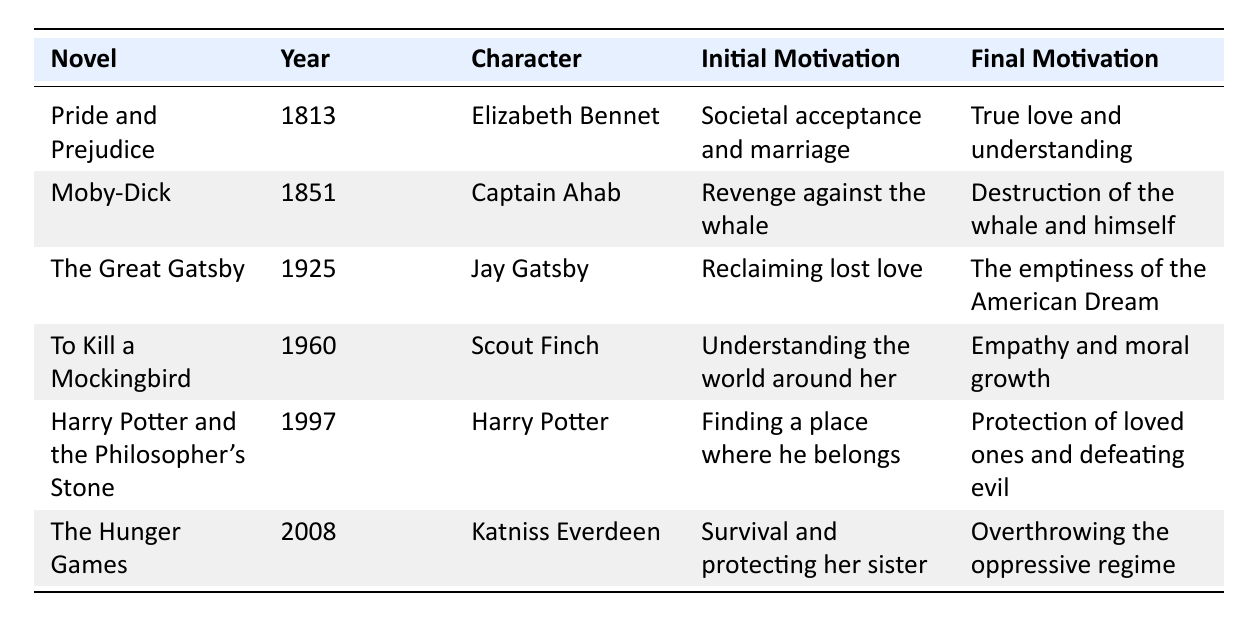What is the title of the novel published in 1925? The table lists the novel titles along with their publication years. By locating the year 1925 in the "Year" column, we find that the corresponding novel is "The Great Gatsby."
Answer: The Great Gatsby Who is the main character of "To Kill a Mockingbird"? The table specifies the main characters for each novel under the "Character" column. For the novel "To Kill a Mockingbird," the main character listed is "Scout Finch."
Answer: Scout Finch What was Elizabeth Bennet's initial motivation? The initial motivation for each character is given in the "Initial Motivation" column. For Elizabeth Bennet from "Pride and Prejudice," her initial motivation is societal acceptance and marriage.
Answer: Societal acceptance and marriage How many novels were published after 1950? To answer, we check the publication years in the "Year" column and count the novels published after 1950. The novels "To Kill a Mockingbird," "Harry Potter and the Philosopher's Stone," and "The Hunger Games" were published after 1950, totaling 3 novels.
Answer: 3 Which character transitions from revenge to self-destruction? By examining the evolution of each character in the table, we look for one whose journey ends in self-destruction. Captain Ahab from "Moby-Dick" evolves from seeking revenge against the whale to destruction of the whale and himself.
Answer: Captain Ahab Is Scout Finch's final motivation related to social issues? Examining the final motivations listed in the table, we see that Scout Finch's final motivation is empathy and moral growth, which indicates awareness of social issues. Therefore, the answer is yes.
Answer: Yes Which character experiences a change in motivation related to the concept of love? We review the "Initial Motivation" and "Final Motivation" columns for any characters associated with love. Jay Gatsby in "The Great Gatsby" starts with reclaiming lost love and ends with the realization of the emptiness of the American Dream, linking both motivations to love.
Answer: Jay Gatsby What is the difference between Katniss Everdeen's initial and final motivations? To find the difference, we identify Katniss Everdeen's initial motivation (survival and protecting her sister) and her final motivation (overthrowing the oppressive regime). The difference reflects a transition from personal survival to broader societal change.
Answer: Transition from personal survival to societal change Which character's motivation evolved significantly towards understanding moral complexities? By reviewing the table, we find that Scout Finch from "To Kill a Mockingbird" evolves from seeking understanding of the world to gaining awareness of social injustices, indicating a significant evolution in understanding moral complexities.
Answer: Scout Finch From the data, which novel explores the theme of the American Dream? We analyze the characters' final motivations and find that Jay Gatsby's conclusion in "The Great Gatsby" directly addresses the emptiness of the American Dream. Thus, this novel explores that theme.
Answer: The Great Gatsby 